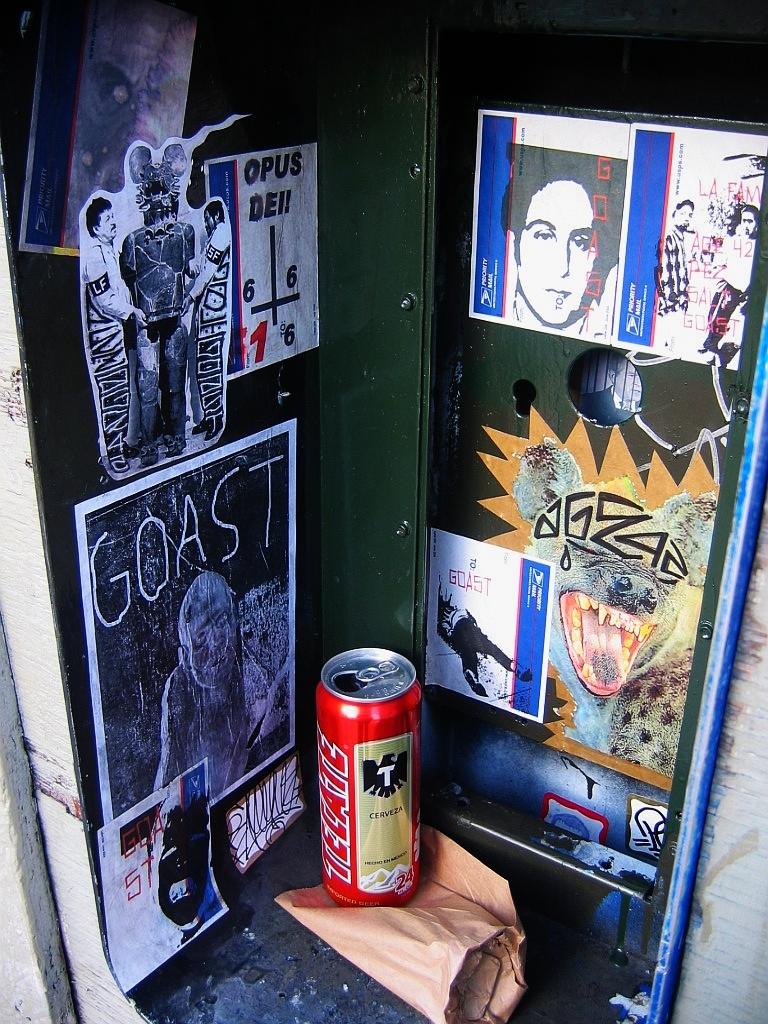What name is written in white on the black and white scary photo?
Offer a very short reply. Goast. 